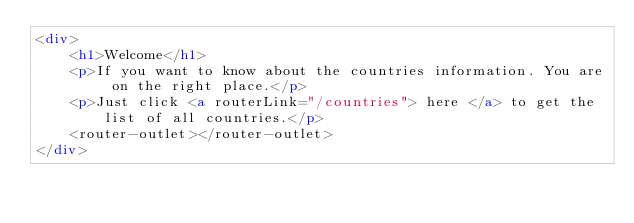Convert code to text. <code><loc_0><loc_0><loc_500><loc_500><_HTML_><div>
    <h1>Welcome</h1>
    <p>If you want to know about the countries information. You are on the right place.</p>
    <p>Just click <a routerLink="/countries"> here </a> to get the list of all countries.</p>
    <router-outlet></router-outlet>
</div></code> 